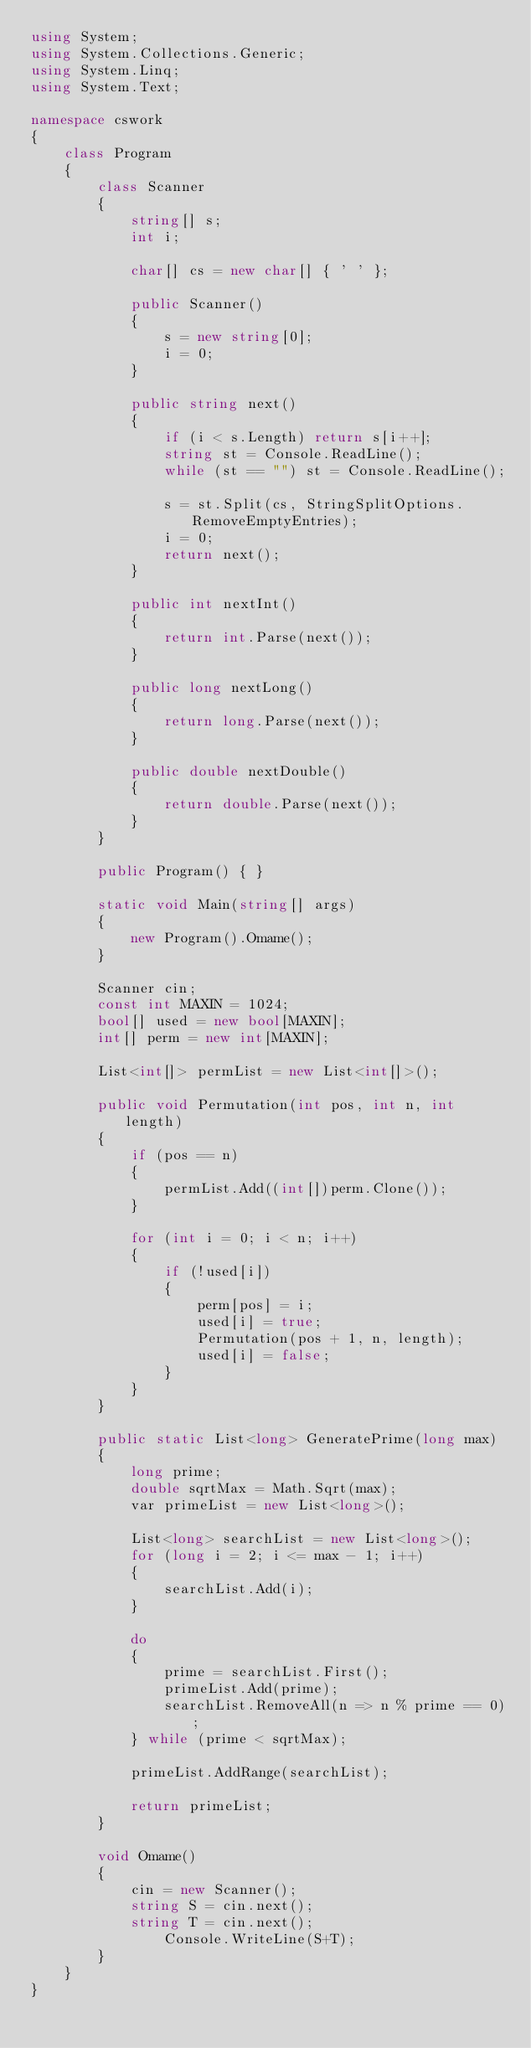Convert code to text. <code><loc_0><loc_0><loc_500><loc_500><_C#_>using System;
using System.Collections.Generic;
using System.Linq;
using System.Text;

namespace cswork
{
    class Program
    {
        class Scanner
        {
            string[] s;
            int i;

            char[] cs = new char[] { ' ' };

            public Scanner()
            {
                s = new string[0];
                i = 0;
            }

            public string next()
            {
                if (i < s.Length) return s[i++];
                string st = Console.ReadLine();
                while (st == "") st = Console.ReadLine();

                s = st.Split(cs, StringSplitOptions.RemoveEmptyEntries);
                i = 0;
                return next();
            }

            public int nextInt()
            {
                return int.Parse(next());
            }

            public long nextLong()
            {
                return long.Parse(next());
            }

            public double nextDouble()
            {
                return double.Parse(next());
            }
        }

        public Program() { }

        static void Main(string[] args)
        {
            new Program().Omame();
        }

        Scanner cin;
        const int MAXIN = 1024;
        bool[] used = new bool[MAXIN];
        int[] perm = new int[MAXIN];

        List<int[]> permList = new List<int[]>();

        public void Permutation(int pos, int n, int length)
        {
            if (pos == n)
            {
                permList.Add((int[])perm.Clone());
            }

            for (int i = 0; i < n; i++)
            {
                if (!used[i])
                {
                    perm[pos] = i;
                    used[i] = true;
                    Permutation(pos + 1, n, length);
                    used[i] = false;
                }
            }
        }

        public static List<long> GeneratePrime(long max)
        {
            long prime;
            double sqrtMax = Math.Sqrt(max);
            var primeList = new List<long>();

            List<long> searchList = new List<long>();
            for (long i = 2; i <= max - 1; i++)
            {
                searchList.Add(i);
            }

            do
            {
                prime = searchList.First();
                primeList.Add(prime);
                searchList.RemoveAll(n => n % prime == 0);
            } while (prime < sqrtMax);

            primeList.AddRange(searchList);

            return primeList;
        }

        void Omame()
        {
            cin = new Scanner();
            string S = cin.next();
            string T = cin.next();
                Console.WriteLine(S+T);
        }
    }
}
</code> 